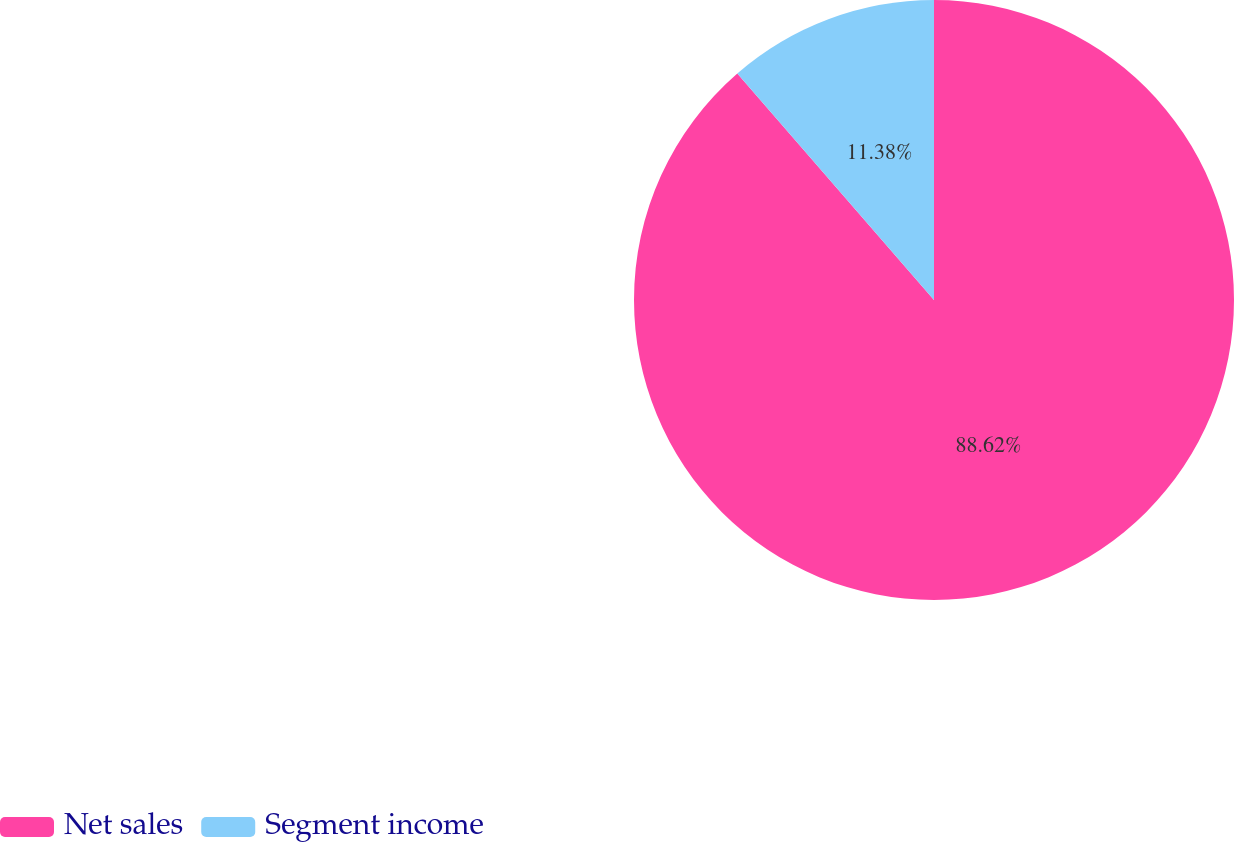Convert chart to OTSL. <chart><loc_0><loc_0><loc_500><loc_500><pie_chart><fcel>Net sales<fcel>Segment income<nl><fcel>88.62%<fcel>11.38%<nl></chart> 